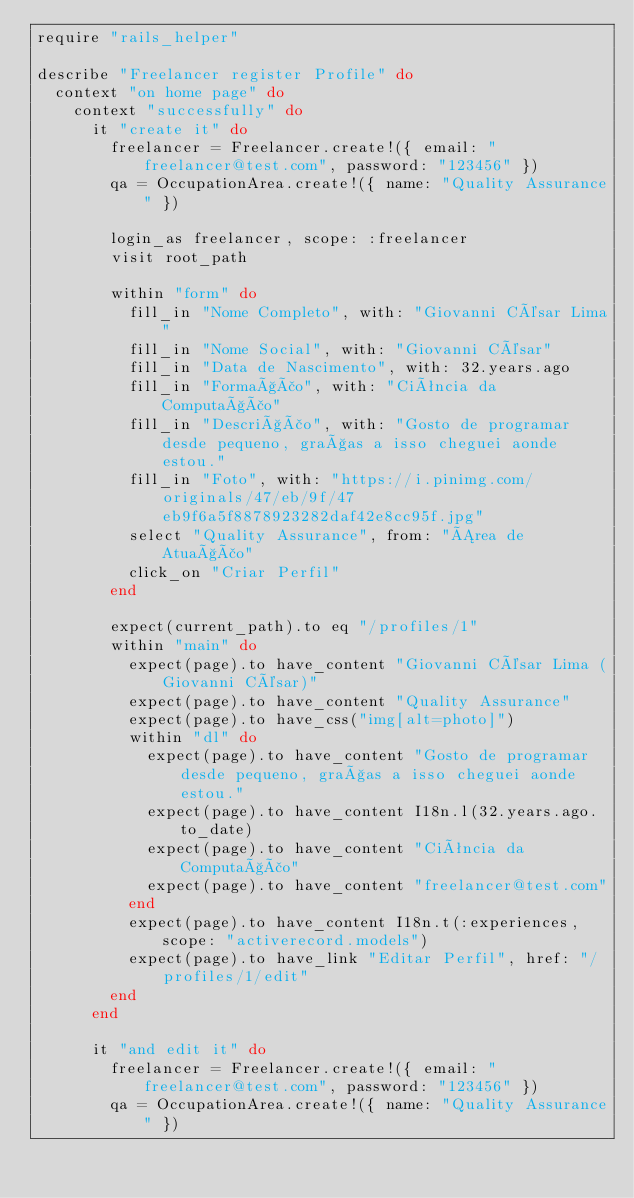<code> <loc_0><loc_0><loc_500><loc_500><_Ruby_>require "rails_helper"

describe "Freelancer register Profile" do
  context "on home page" do
    context "successfully" do
      it "create it" do
        freelancer = Freelancer.create!({ email: "freelancer@test.com", password: "123456" })
        qa = OccupationArea.create!({ name: "Quality Assurance" })

        login_as freelancer, scope: :freelancer
        visit root_path

        within "form" do
          fill_in "Nome Completo", with: "Giovanni César Lima"
          fill_in "Nome Social", with: "Giovanni César"
          fill_in "Data de Nascimento", with: 32.years.ago
          fill_in "Formação", with: "Ciência da Computação"
          fill_in "Descrição", with: "Gosto de programar desde pequeno, graças a isso cheguei aonde estou."
          fill_in "Foto", with: "https://i.pinimg.com/originals/47/eb/9f/47eb9f6a5f8878923282daf42e8cc95f.jpg"
          select "Quality Assurance", from: "Área de Atuação"
          click_on "Criar Perfil"
        end

        expect(current_path).to eq "/profiles/1"
        within "main" do
          expect(page).to have_content "Giovanni César Lima (Giovanni César)"
          expect(page).to have_content "Quality Assurance"
          expect(page).to have_css("img[alt=photo]")
          within "dl" do
            expect(page).to have_content "Gosto de programar desde pequeno, graças a isso cheguei aonde estou."
            expect(page).to have_content I18n.l(32.years.ago.to_date)
            expect(page).to have_content "Ciência da Computação"
            expect(page).to have_content "freelancer@test.com"
          end
          expect(page).to have_content I18n.t(:experiences, scope: "activerecord.models")
          expect(page).to have_link "Editar Perfil", href: "/profiles/1/edit"
        end
      end

      it "and edit it" do
        freelancer = Freelancer.create!({ email: "freelancer@test.com", password: "123456" })
        qa = OccupationArea.create!({ name: "Quality Assurance" })</code> 